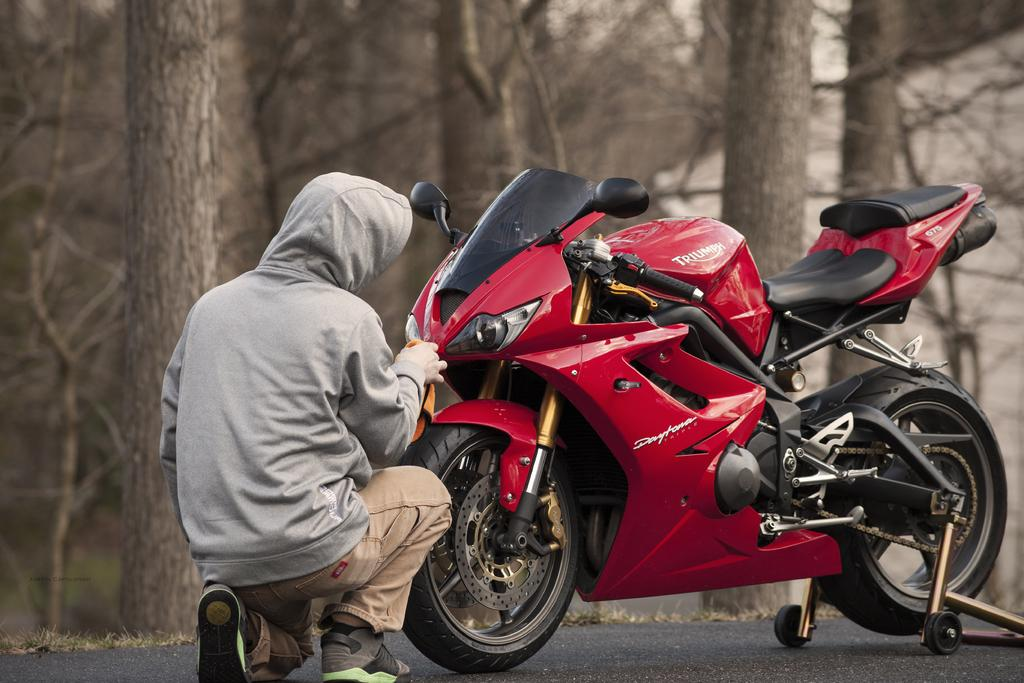What is on the road in the image? There is a vehicle on the road in the image. What is the person in the image doing? The person is sitting and cleaning in the image. What can be seen in the background of the image? There are trees visible in the image. What type of pump is being used by the person in the image? There is no pump visible in the image; the person is sitting and cleaning. What time of day is it in the image, considering the presence of the morning? The provided facts do not mention the time of day, and there is no indication of morning in the image. 